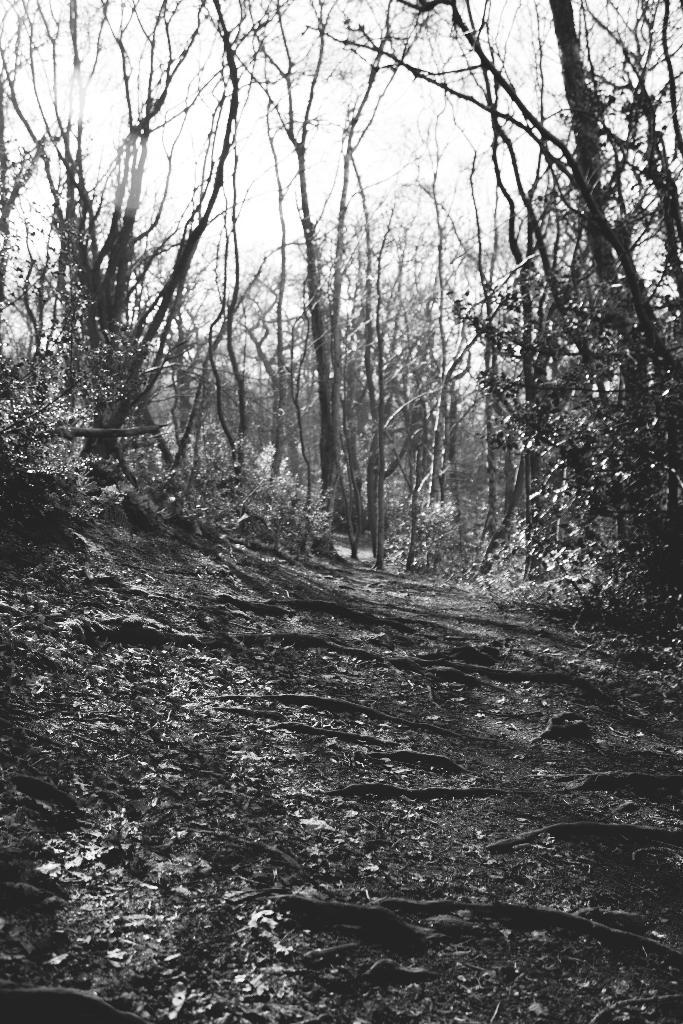What is the color scheme of the image? The image is black and white. What can be seen on the ground at the bottom of the image? There are leaves on the ground at the bottom of the image. What is visible in the background of the image? There are trees and the sky visible in the background of the image. What story is being told by the veins in the image? There are no veins present in the image, as it is a black and white image of leaves on the ground and trees in the background. 